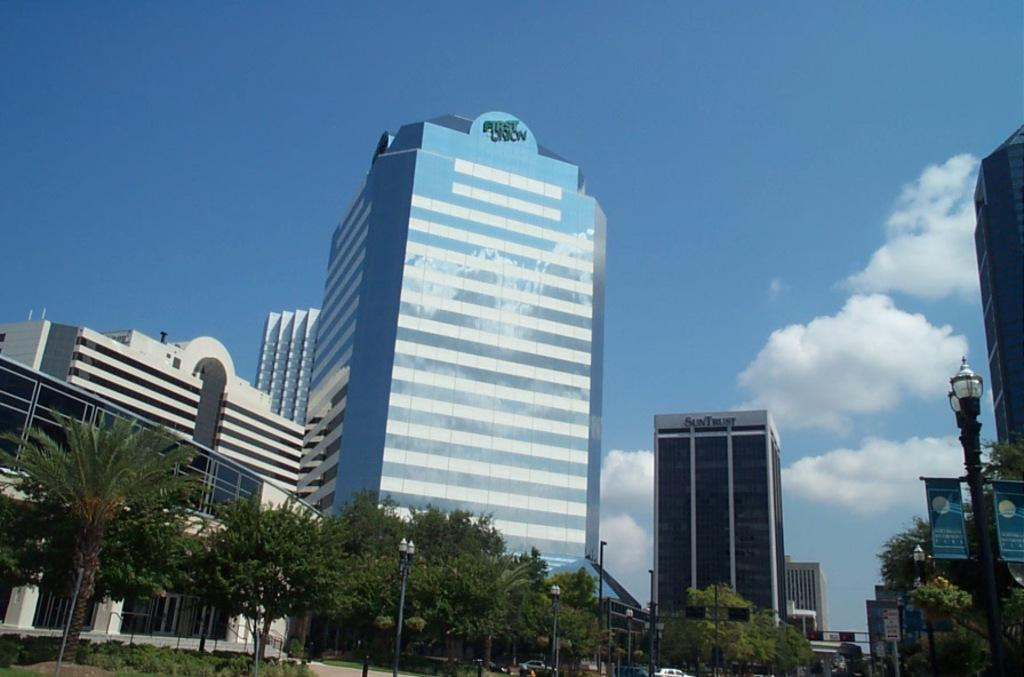What type of structures can be seen in the image? There are buildings in the image. What else can be found in the image besides buildings? There are trees and street lights visible in the image. What is visible in the background of the image? The sky is visible in the background of the image. What can be seen on the right side of the image? There are banners on the right side of the image. Can you see a tent in the image? No, there is no tent present in the image. What type of doll is sitting on the street light? There is no doll present in the image; it only features buildings, trees, street lights, the sky, and banners. 